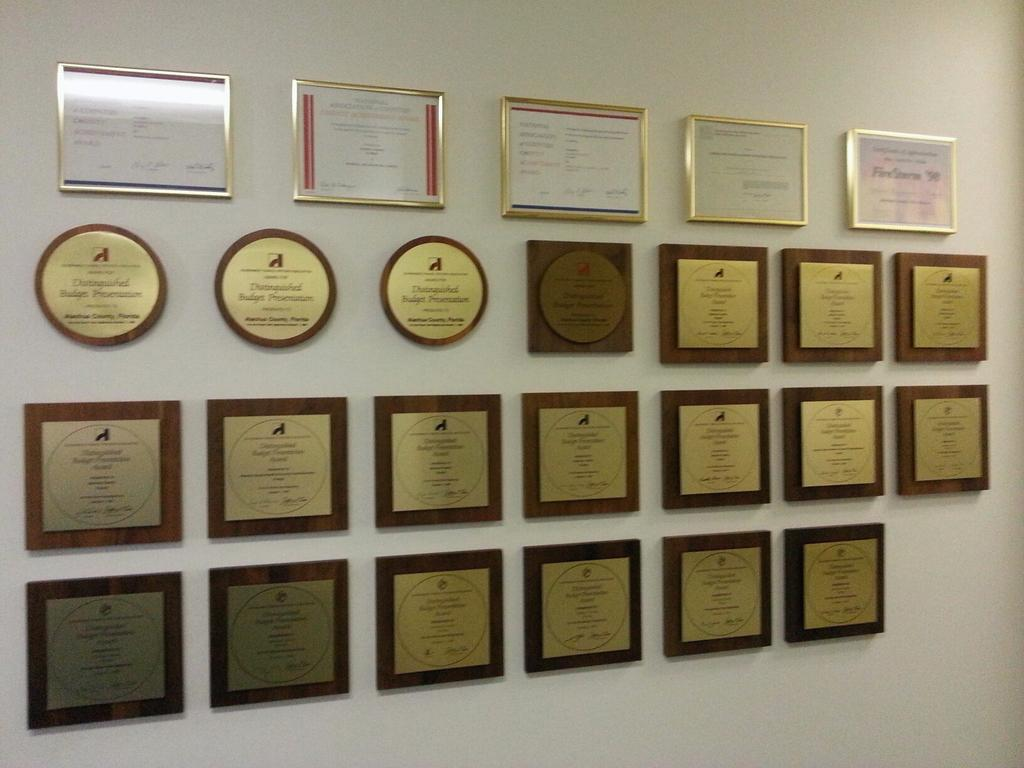What can be seen on the wall in the image? There are frames on the wall in the image. What might be contained within the frames? The contents of the frames are not visible in the image, but they could be photographs, paintings, or other artwork. How many frames are present on the wall? The number of frames on the wall is not specified in the image, but there are at least a few visible. What type of beef is being ordered in the image? There is no mention of beef or any food in the image; it only shows frames on the wall. 